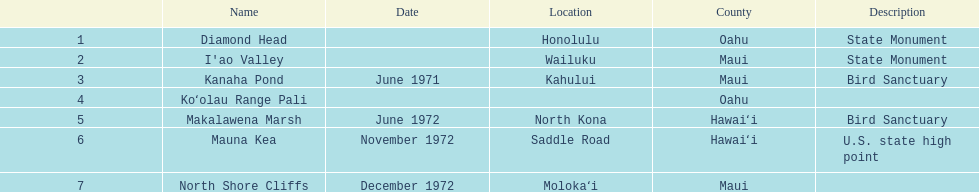What is the overall count of landmarks situated in maui? 3. 